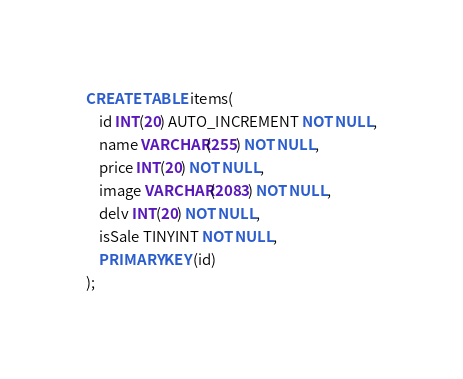<code> <loc_0><loc_0><loc_500><loc_500><_SQL_>CREATE TABLE items(
    id INT(20) AUTO_INCREMENT NOT NULL,
    name VARCHAR(255) NOT NULL,
    price INT(20) NOT NULL,
    image VARCHAR(2083) NOT NULL,
    delv INT(20) NOT NULL,
    isSale TINYINT NOT NULL,
    PRIMARY KEY (id)
);</code> 